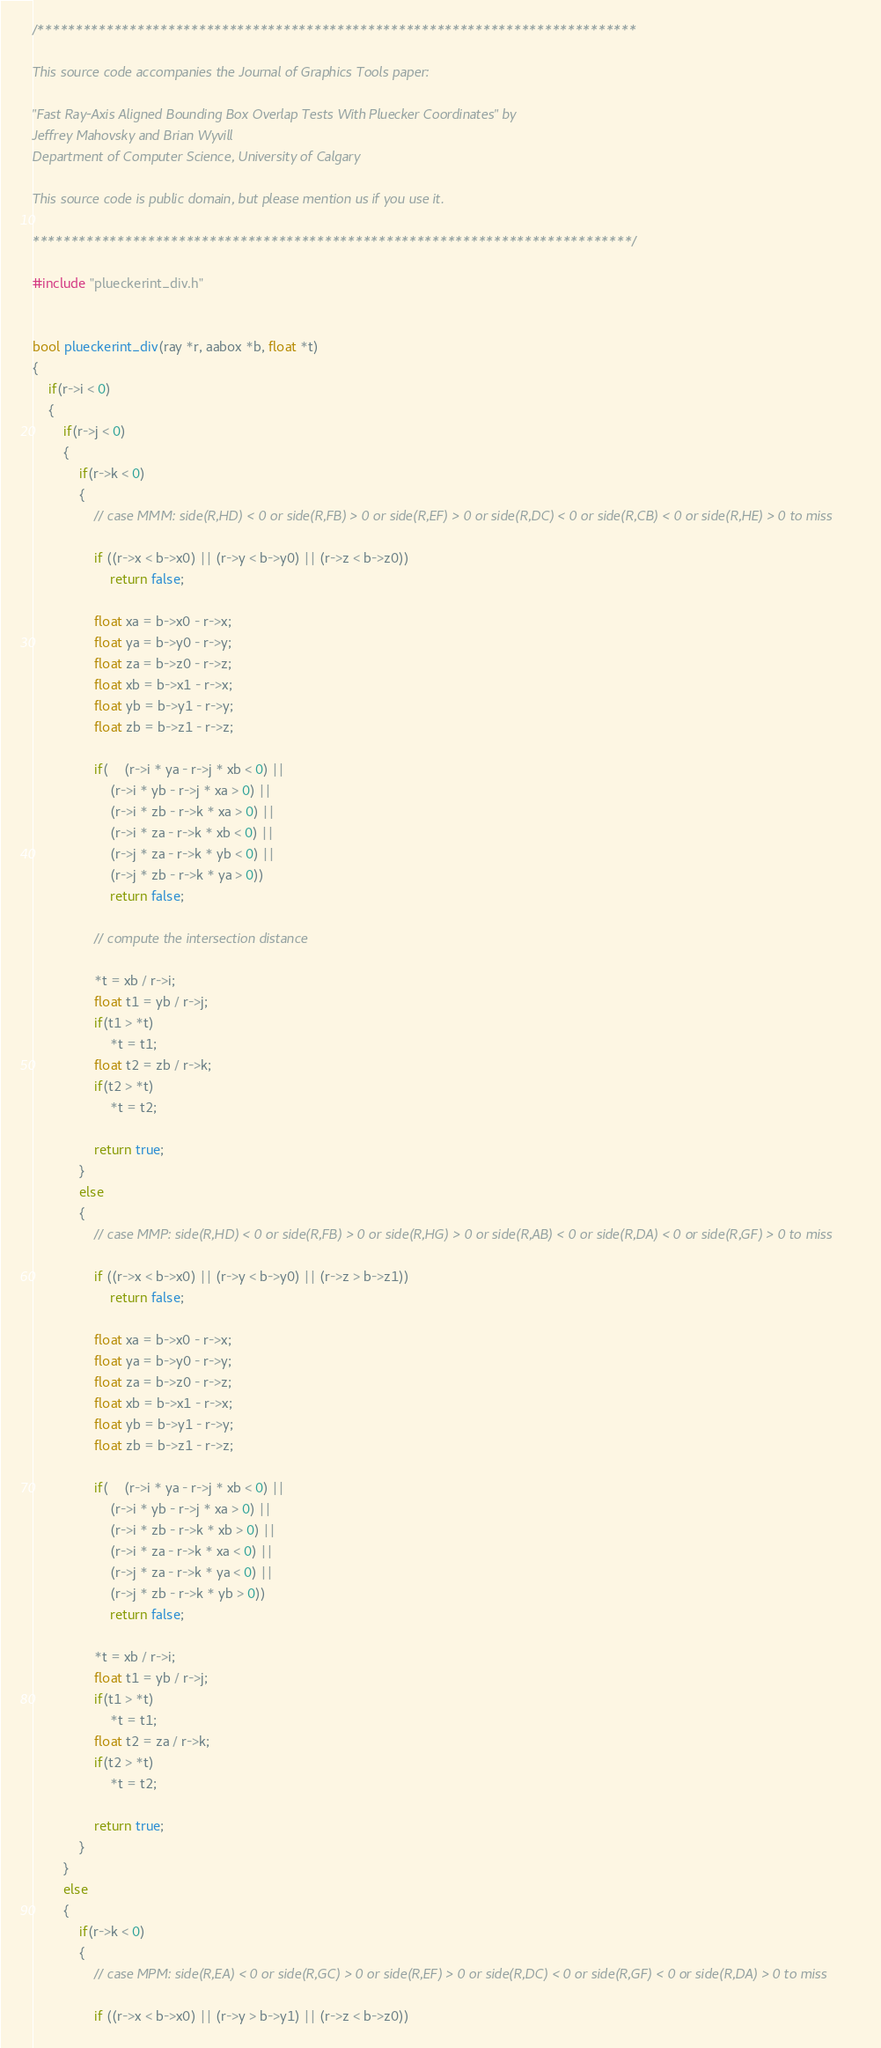Convert code to text. <code><loc_0><loc_0><loc_500><loc_500><_C++_>/******************************************************************************

This source code accompanies the Journal of Graphics Tools paper:

"Fast Ray-Axis Aligned Bounding Box Overlap Tests With Pluecker Coordinates" by
Jeffrey Mahovsky and Brian Wyvill
Department of Computer Science, University of Calgary

This source code is public domain, but please mention us if you use it.

******************************************************************************/

#include "plueckerint_div.h"


bool plueckerint_div(ray *r, aabox *b, float *t)
{
	if(r->i < 0) 
	{
		if(r->j < 0) 
		{
			if(r->k < 0)
			{
				// case MMM: side(R,HD) < 0 or side(R,FB) > 0 or side(R,EF) > 0 or side(R,DC) < 0 or side(R,CB) < 0 or side(R,HE) > 0 to miss

				if ((r->x < b->x0) || (r->y < b->y0) || (r->z < b->z0))
					return false;

				float xa = b->x0 - r->x; 
				float ya = b->y0 - r->y; 
				float za = b->z0 - r->z; 
				float xb = b->x1 - r->x;
				float yb = b->y1 - r->y;
				float zb = b->z1 - r->z;

				if(	(r->i * ya - r->j * xb < 0) ||
					(r->i * yb - r->j * xa > 0) ||
					(r->i * zb - r->k * xa > 0) ||
					(r->i * za - r->k * xb < 0) ||
					(r->j * za - r->k * yb < 0) ||
					(r->j * zb - r->k * ya > 0))
					return false;

				// compute the intersection distance

				*t = xb / r->i;
				float t1 = yb / r->j;
				if(t1 > *t)
					*t = t1;
				float t2 = zb / r->k;
				if(t2 > *t)
					*t = t2;

				return true;
			}
			else
			{
				// case MMP: side(R,HD) < 0 or side(R,FB) > 0 or side(R,HG) > 0 or side(R,AB) < 0 or side(R,DA) < 0 or side(R,GF) > 0 to miss

				if ((r->x < b->x0) || (r->y < b->y0) || (r->z > b->z1))
					return false;

				float xa = b->x0 - r->x; 
				float ya = b->y0 - r->y; 
				float za = b->z0 - r->z; 
				float xb = b->x1 - r->x;
				float yb = b->y1 - r->y;
				float zb = b->z1 - r->z;

				if(	(r->i * ya - r->j * xb < 0) ||
					(r->i * yb - r->j * xa > 0) ||
					(r->i * zb - r->k * xb > 0) ||
					(r->i * za - r->k * xa < 0) ||
					(r->j * za - r->k * ya < 0) ||
					(r->j * zb - r->k * yb > 0))
					return false;

				*t = xb / r->i;
				float t1 = yb / r->j;
				if(t1 > *t)
					*t = t1;
				float t2 = za / r->k;
				if(t2 > *t)
					*t = t2;

				return true;
			}
		} 
		else 
		{
			if(r->k < 0)
			{
				// case MPM: side(R,EA) < 0 or side(R,GC) > 0 or side(R,EF) > 0 or side(R,DC) < 0 or side(R,GF) < 0 or side(R,DA) > 0 to miss

				if ((r->x < b->x0) || (r->y > b->y1) || (r->z < b->z0))</code> 